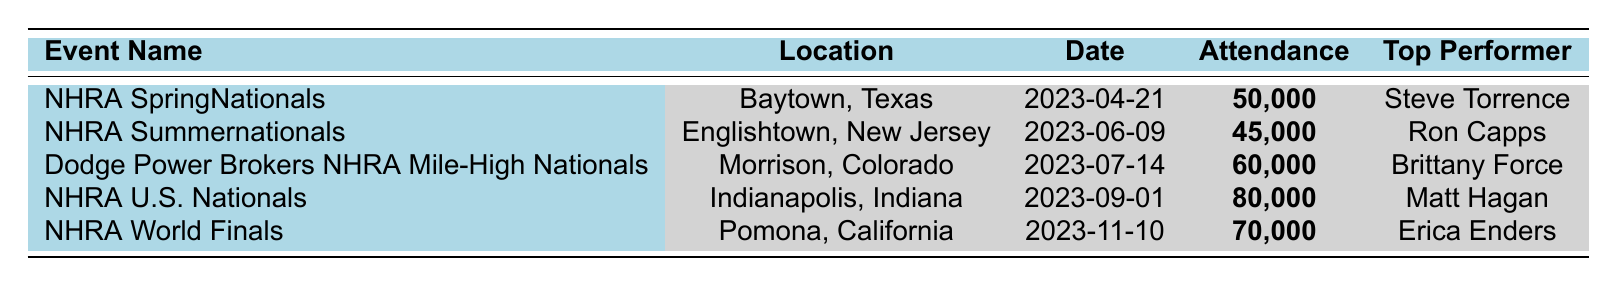What event had the highest attendance? By inspecting the attendance column, the NHRA U.S. Nationals shows the highest attendance value of 80,000.
Answer: NHRA U.S. Nationals How many events were held in New Jersey? The only event listed in New Jersey is the NHRA Summernationals, which confirms there was one event held in that state.
Answer: 1 What is the total attendance for all the events listed? Adding up the attendance values: 50,000 + 45,000 + 60,000 + 80,000 + 70,000 = 305,000 for all events combined.
Answer: 305,000 Which event took place on July 14, 2023? Referring to the date column, the event on July 14, 2023, is the Dodge Power Brokers NHRA Mile-High Nationals.
Answer: Dodge Power Brokers NHRA Mile-High Nationals Is there an event with an attendance of 45,000? Yes, the NHRA Summernationals has an attendance of 45,000, as indicated in the attendance column.
Answer: Yes What is the difference in attendance between the event with the highest and lowest attendance? The highest attendance is 80,000 (NHRA U.S. Nationals) and the lowest is 45,000 (NHRA Summernationals). The difference is 80,000 - 45,000 = 35,000.
Answer: 35,000 Which is the only event categorized as "Pro Stock"? The NHRA World Finals is the only event listed under the Pro Stock category.
Answer: NHRA World Finals What is the average attendance across all events? To find the average, sum the attendances (305,000) and divide by the number of events (5): 305,000 / 5 = 61,000.
Answer: 61,000 Which two events took place in the same month? Both the NHRA U.S. Nationals and the NHRA World Finals took place in September and November, respectively; hence, they did not occur in the same month.
Answer: No Who was the top performer at the event with the second-highest attendance? The event with the second-highest attendance is the NHRA World Finals with 70,000 attendees, and the top performer there is Erica Enders.
Answer: Erica Enders 